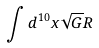<formula> <loc_0><loc_0><loc_500><loc_500>\int d ^ { 1 0 } x \sqrt { G } R</formula> 